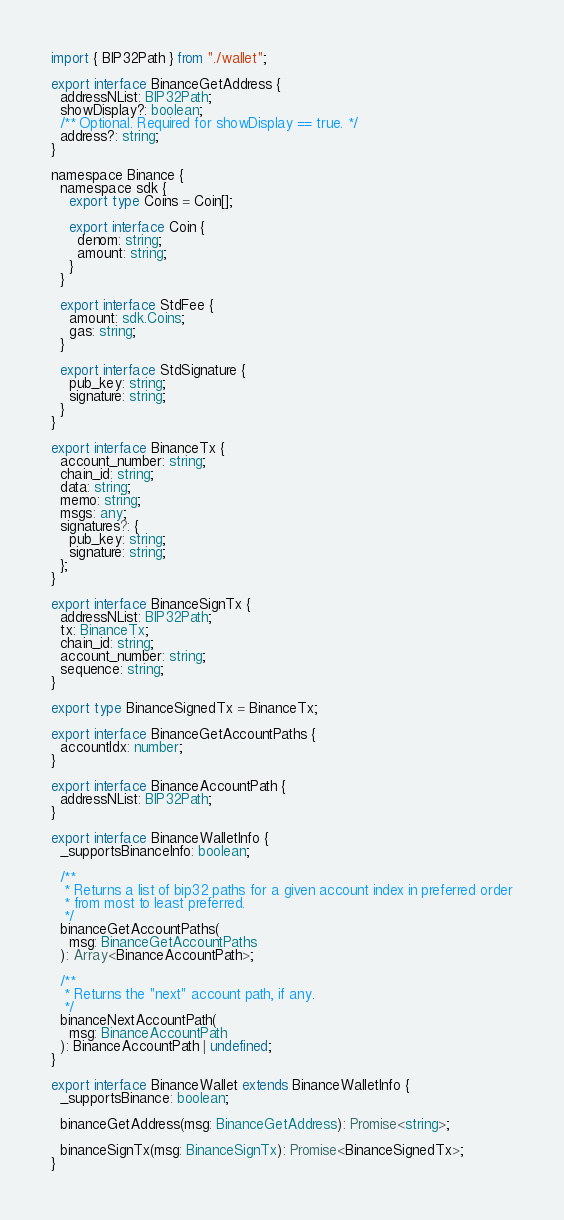<code> <loc_0><loc_0><loc_500><loc_500><_TypeScript_>import { BIP32Path } from "./wallet";

export interface BinanceGetAddress {
  addressNList: BIP32Path;
  showDisplay?: boolean;
  /** Optional. Required for showDisplay == true. */
  address?: string;
}

namespace Binance {
  namespace sdk {
    export type Coins = Coin[];

    export interface Coin {
      denom: string;
      amount: string;
    }
  }

  export interface StdFee {
    amount: sdk.Coins;
    gas: string;
  }

  export interface StdSignature {
    pub_key: string;
    signature: string;
  }
}

export interface BinanceTx {
  account_number: string;
  chain_id: string;
  data: string;
  memo: string;
  msgs: any;
  signatures?: {
    pub_key: string;
    signature: string;
  };
}

export interface BinanceSignTx {
  addressNList: BIP32Path;
  tx: BinanceTx;
  chain_id: string;
  account_number: string;
  sequence: string;
}

export type BinanceSignedTx = BinanceTx;

export interface BinanceGetAccountPaths {
  accountIdx: number;
}

export interface BinanceAccountPath {
  addressNList: BIP32Path;
}

export interface BinanceWalletInfo {
  _supportsBinanceInfo: boolean;

  /**
   * Returns a list of bip32 paths for a given account index in preferred order
   * from most to least preferred.
   */
  binanceGetAccountPaths(
    msg: BinanceGetAccountPaths
  ): Array<BinanceAccountPath>;

  /**
   * Returns the "next" account path, if any.
   */
  binanceNextAccountPath(
    msg: BinanceAccountPath
  ): BinanceAccountPath | undefined;
}

export interface BinanceWallet extends BinanceWalletInfo {
  _supportsBinance: boolean;

  binanceGetAddress(msg: BinanceGetAddress): Promise<string>;

  binanceSignTx(msg: BinanceSignTx): Promise<BinanceSignedTx>;
}
</code> 